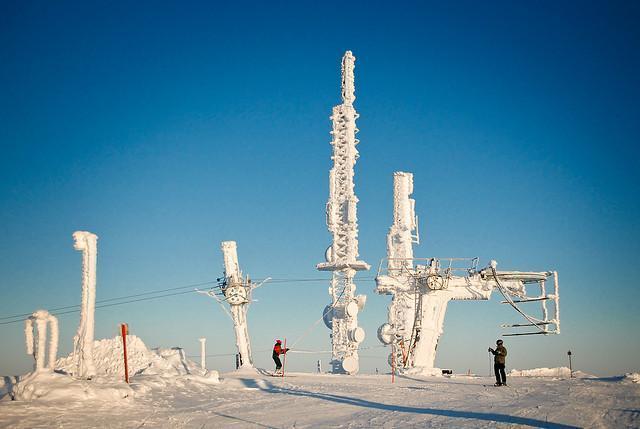Why is the machinery white?
Make your selection and explain in format: 'Answer: answer
Rationale: rationale.'
Options: Toilet paper, snow covered, styrofoam, painted white. Answer: snow covered.
Rationale: It is cold. 